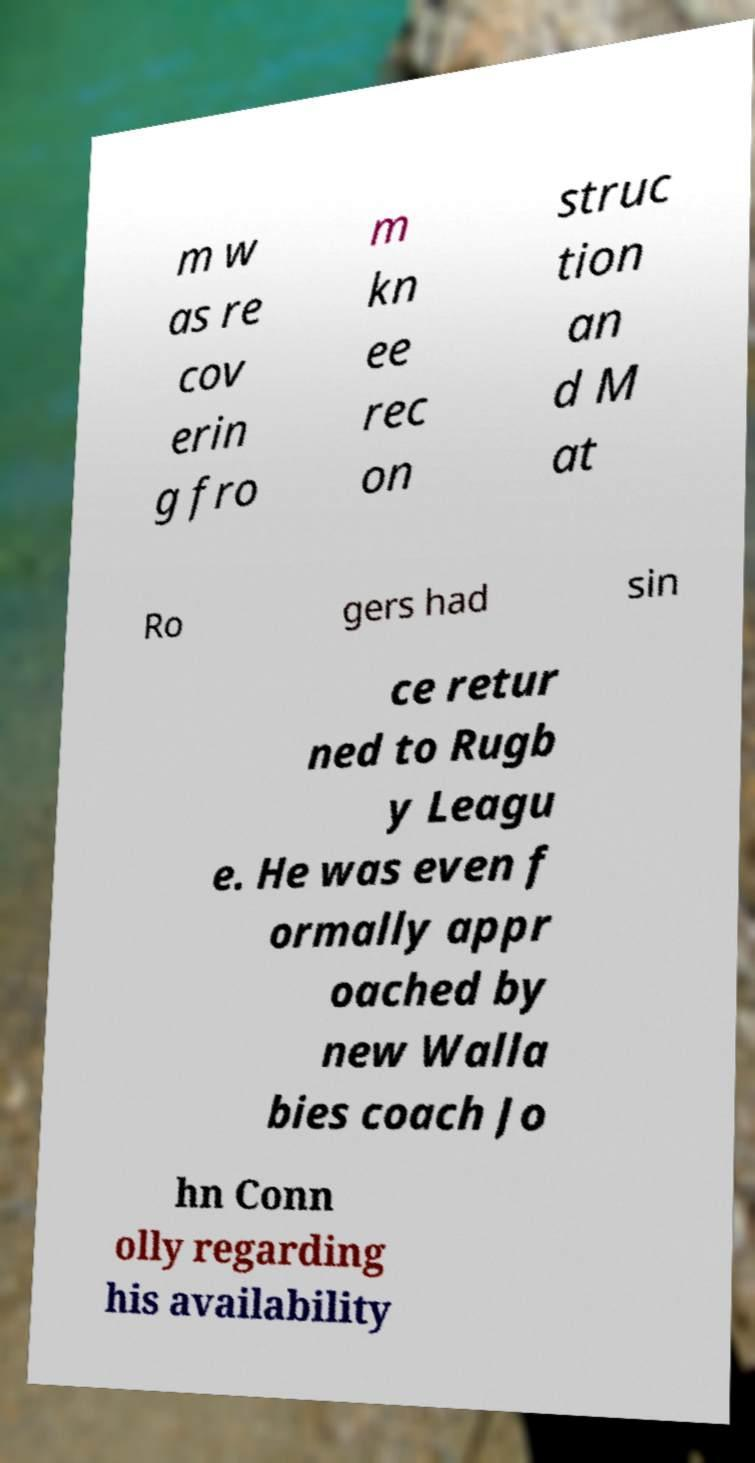For documentation purposes, I need the text within this image transcribed. Could you provide that? m w as re cov erin g fro m kn ee rec on struc tion an d M at Ro gers had sin ce retur ned to Rugb y Leagu e. He was even f ormally appr oached by new Walla bies coach Jo hn Conn olly regarding his availability 